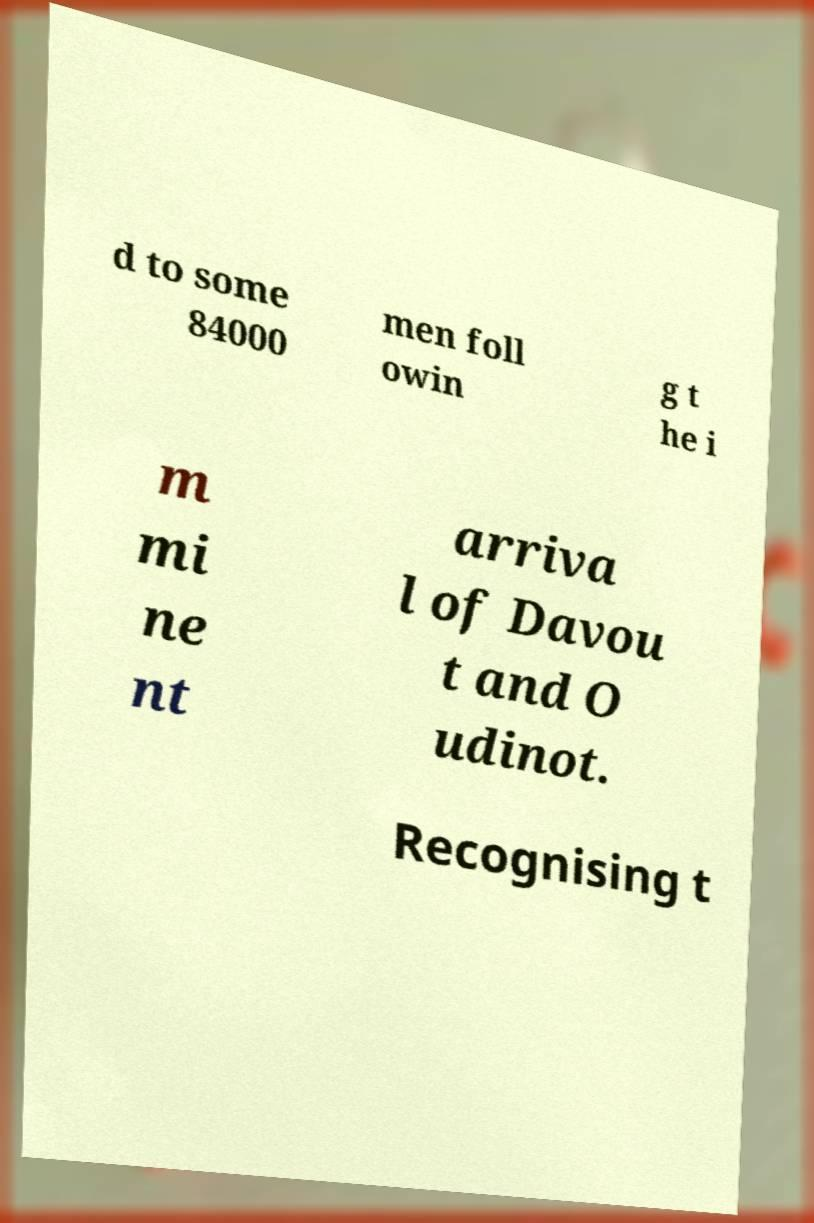Could you assist in decoding the text presented in this image and type it out clearly? d to some 84000 men foll owin g t he i m mi ne nt arriva l of Davou t and O udinot. Recognising t 